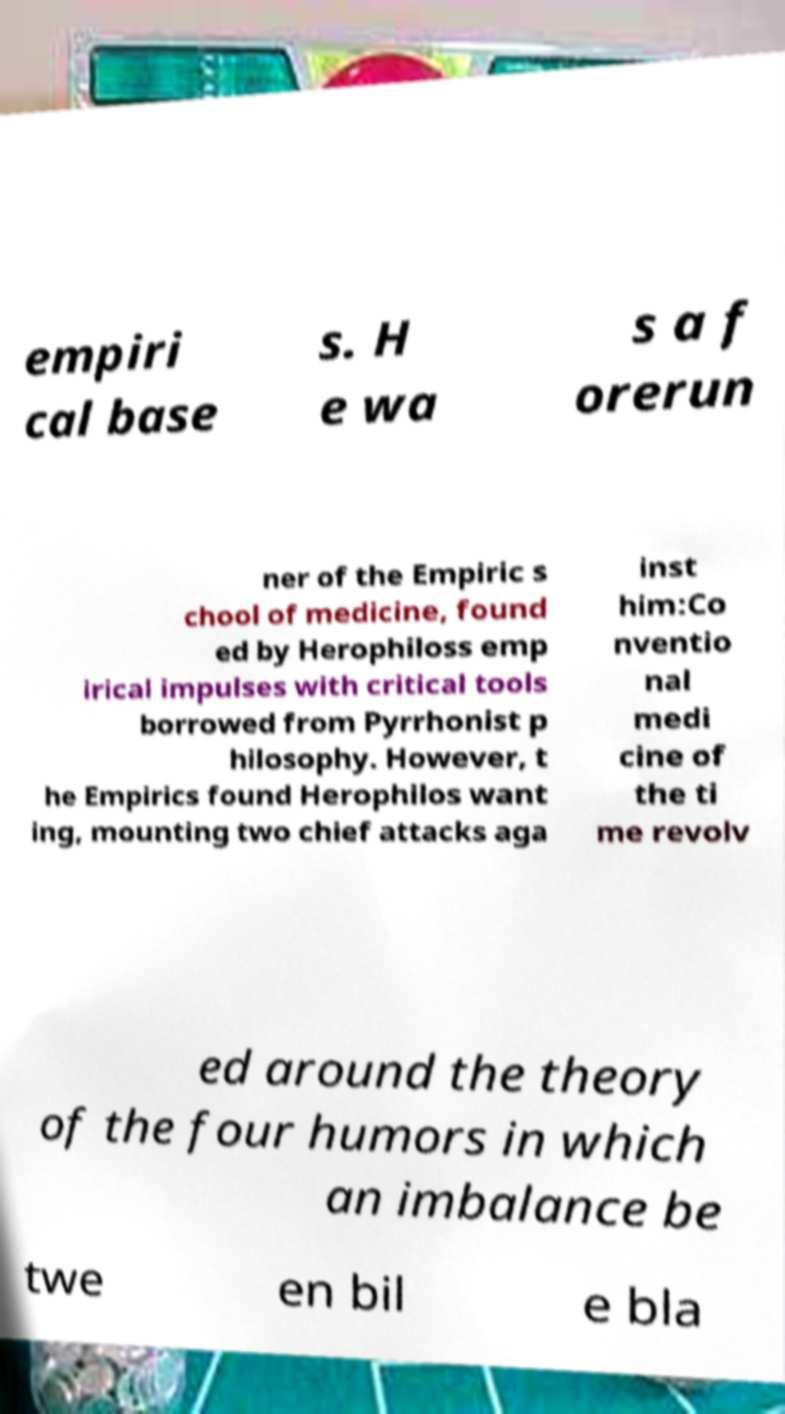Please read and relay the text visible in this image. What does it say? empiri cal base s. H e wa s a f orerun ner of the Empiric s chool of medicine, found ed by Herophiloss emp irical impulses with critical tools borrowed from Pyrrhonist p hilosophy. However, t he Empirics found Herophilos want ing, mounting two chief attacks aga inst him:Co nventio nal medi cine of the ti me revolv ed around the theory of the four humors in which an imbalance be twe en bil e bla 